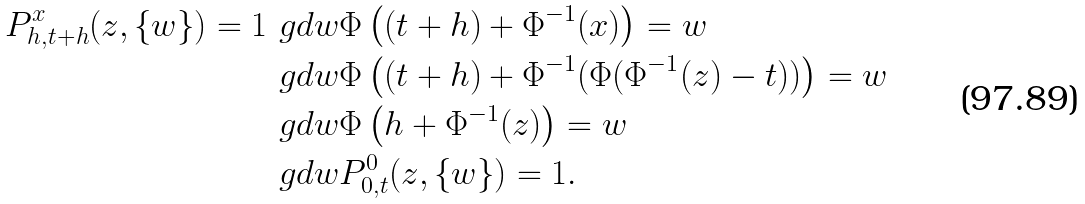Convert formula to latex. <formula><loc_0><loc_0><loc_500><loc_500>P _ { h , t + h } ^ { x } ( z , \{ w \} ) = 1 & \ g d w \Phi \left ( ( t + h ) + \Phi ^ { - 1 } ( x ) \right ) = w \\ & \ g d w \Phi \left ( ( t + h ) + \Phi ^ { - 1 } ( \Phi ( \Phi ^ { - 1 } ( z ) - t ) ) \right ) = w \\ & \ g d w \Phi \left ( h + \Phi ^ { - 1 } ( z ) \right ) = w \\ & \ g d w P _ { 0 , t } ^ { 0 } ( z , \{ w \} ) = 1 .</formula> 